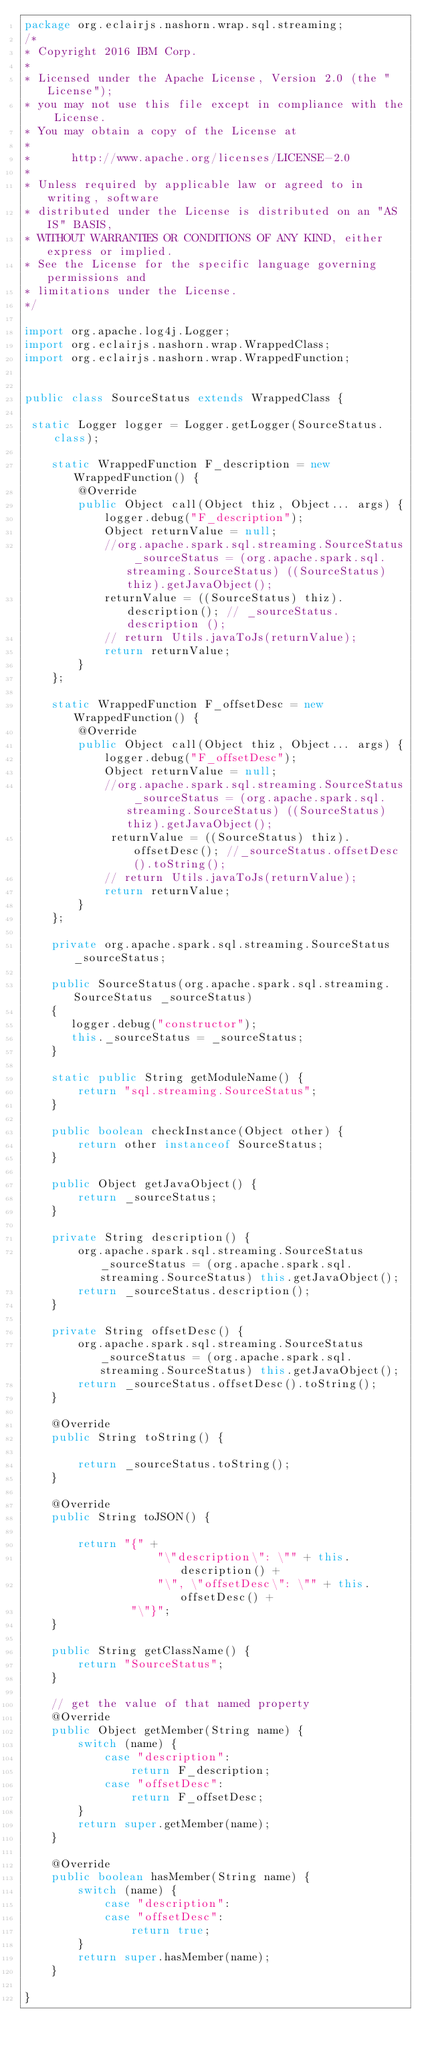<code> <loc_0><loc_0><loc_500><loc_500><_Java_>package org.eclairjs.nashorn.wrap.sql.streaming;
/*                                                                         
* Copyright 2016 IBM Corp.                                                 
*                                                                          
* Licensed under the Apache License, Version 2.0 (the "License");          
* you may not use this file except in compliance with the License.         
* You may obtain a copy of the License at                                  
*                                                                          
*      http://www.apache.org/licenses/LICENSE-2.0                          
*                                                                          
* Unless required by applicable law or agreed to in writing, software      
* distributed under the License is distributed on an "AS IS" BASIS,        
* WITHOUT WARRANTIES OR CONDITIONS OF ANY KIND, either express or implied. 
* See the License for the specific language governing permissions and      
* limitations under the License.                                           
*/

import org.apache.log4j.Logger;
import org.eclairjs.nashorn.wrap.WrappedClass;
import org.eclairjs.nashorn.wrap.WrappedFunction;


public class SourceStatus extends WrappedClass {

 static Logger logger = Logger.getLogger(SourceStatus.class);

    static WrappedFunction F_description = new WrappedFunction() {
        @Override
        public Object call(Object thiz, Object... args) {
            logger.debug("F_description");
            Object returnValue = null;
            //org.apache.spark.sql.streaming.SourceStatus _sourceStatus = (org.apache.spark.sql.streaming.SourceStatus) ((SourceStatus) thiz).getJavaObject();
            returnValue = ((SourceStatus) thiz).description(); // _sourceStatus.description ();
            // return Utils.javaToJs(returnValue);
            return returnValue;
        }
    };

    static WrappedFunction F_offsetDesc = new WrappedFunction() {
        @Override
        public Object call(Object thiz, Object... args) {
            logger.debug("F_offsetDesc");
            Object returnValue = null;
            //org.apache.spark.sql.streaming.SourceStatus _sourceStatus = (org.apache.spark.sql.streaming.SourceStatus) ((SourceStatus) thiz).getJavaObject();
             returnValue = ((SourceStatus) thiz).offsetDesc(); //_sourceStatus.offsetDesc().toString();
            // return Utils.javaToJs(returnValue);
            return returnValue;
        }
    };

    private org.apache.spark.sql.streaming.SourceStatus _sourceStatus;

    public SourceStatus(org.apache.spark.sql.streaming.SourceStatus _sourceStatus)
    {
       logger.debug("constructor");
       this._sourceStatus = _sourceStatus;
    }

    static public String getModuleName() {
        return "sql.streaming.SourceStatus";
    }

    public boolean checkInstance(Object other) {
        return other instanceof SourceStatus;
    }

    public Object getJavaObject() {
        return _sourceStatus;
    }

    private String description() {
        org.apache.spark.sql.streaming.SourceStatus _sourceStatus = (org.apache.spark.sql.streaming.SourceStatus) this.getJavaObject();
        return _sourceStatus.description();
    }

    private String offsetDesc() {
        org.apache.spark.sql.streaming.SourceStatus _sourceStatus = (org.apache.spark.sql.streaming.SourceStatus) this.getJavaObject();
        return _sourceStatus.offsetDesc().toString();
    }

    @Override
    public String toString() {

        return _sourceStatus.toString();
    }

    @Override
    public String toJSON() {

        return "{" +
                    "\"description\": \"" + this.description() +
                    "\", \"offsetDesc\": \"" + this.offsetDesc() +
                "\"}";
    }

    public String getClassName() {
        return "SourceStatus";
    }

    // get the value of that named property
    @Override
    public Object getMember(String name) {
        switch (name) {
            case "description":
                return F_description;
            case "offsetDesc":
                return F_offsetDesc;
        }
        return super.getMember(name);
    }

    @Override
    public boolean hasMember(String name) {
        switch (name) {
            case "description":
            case "offsetDesc":
                return true;
        }
        return super.hasMember(name);
    }

}
</code> 